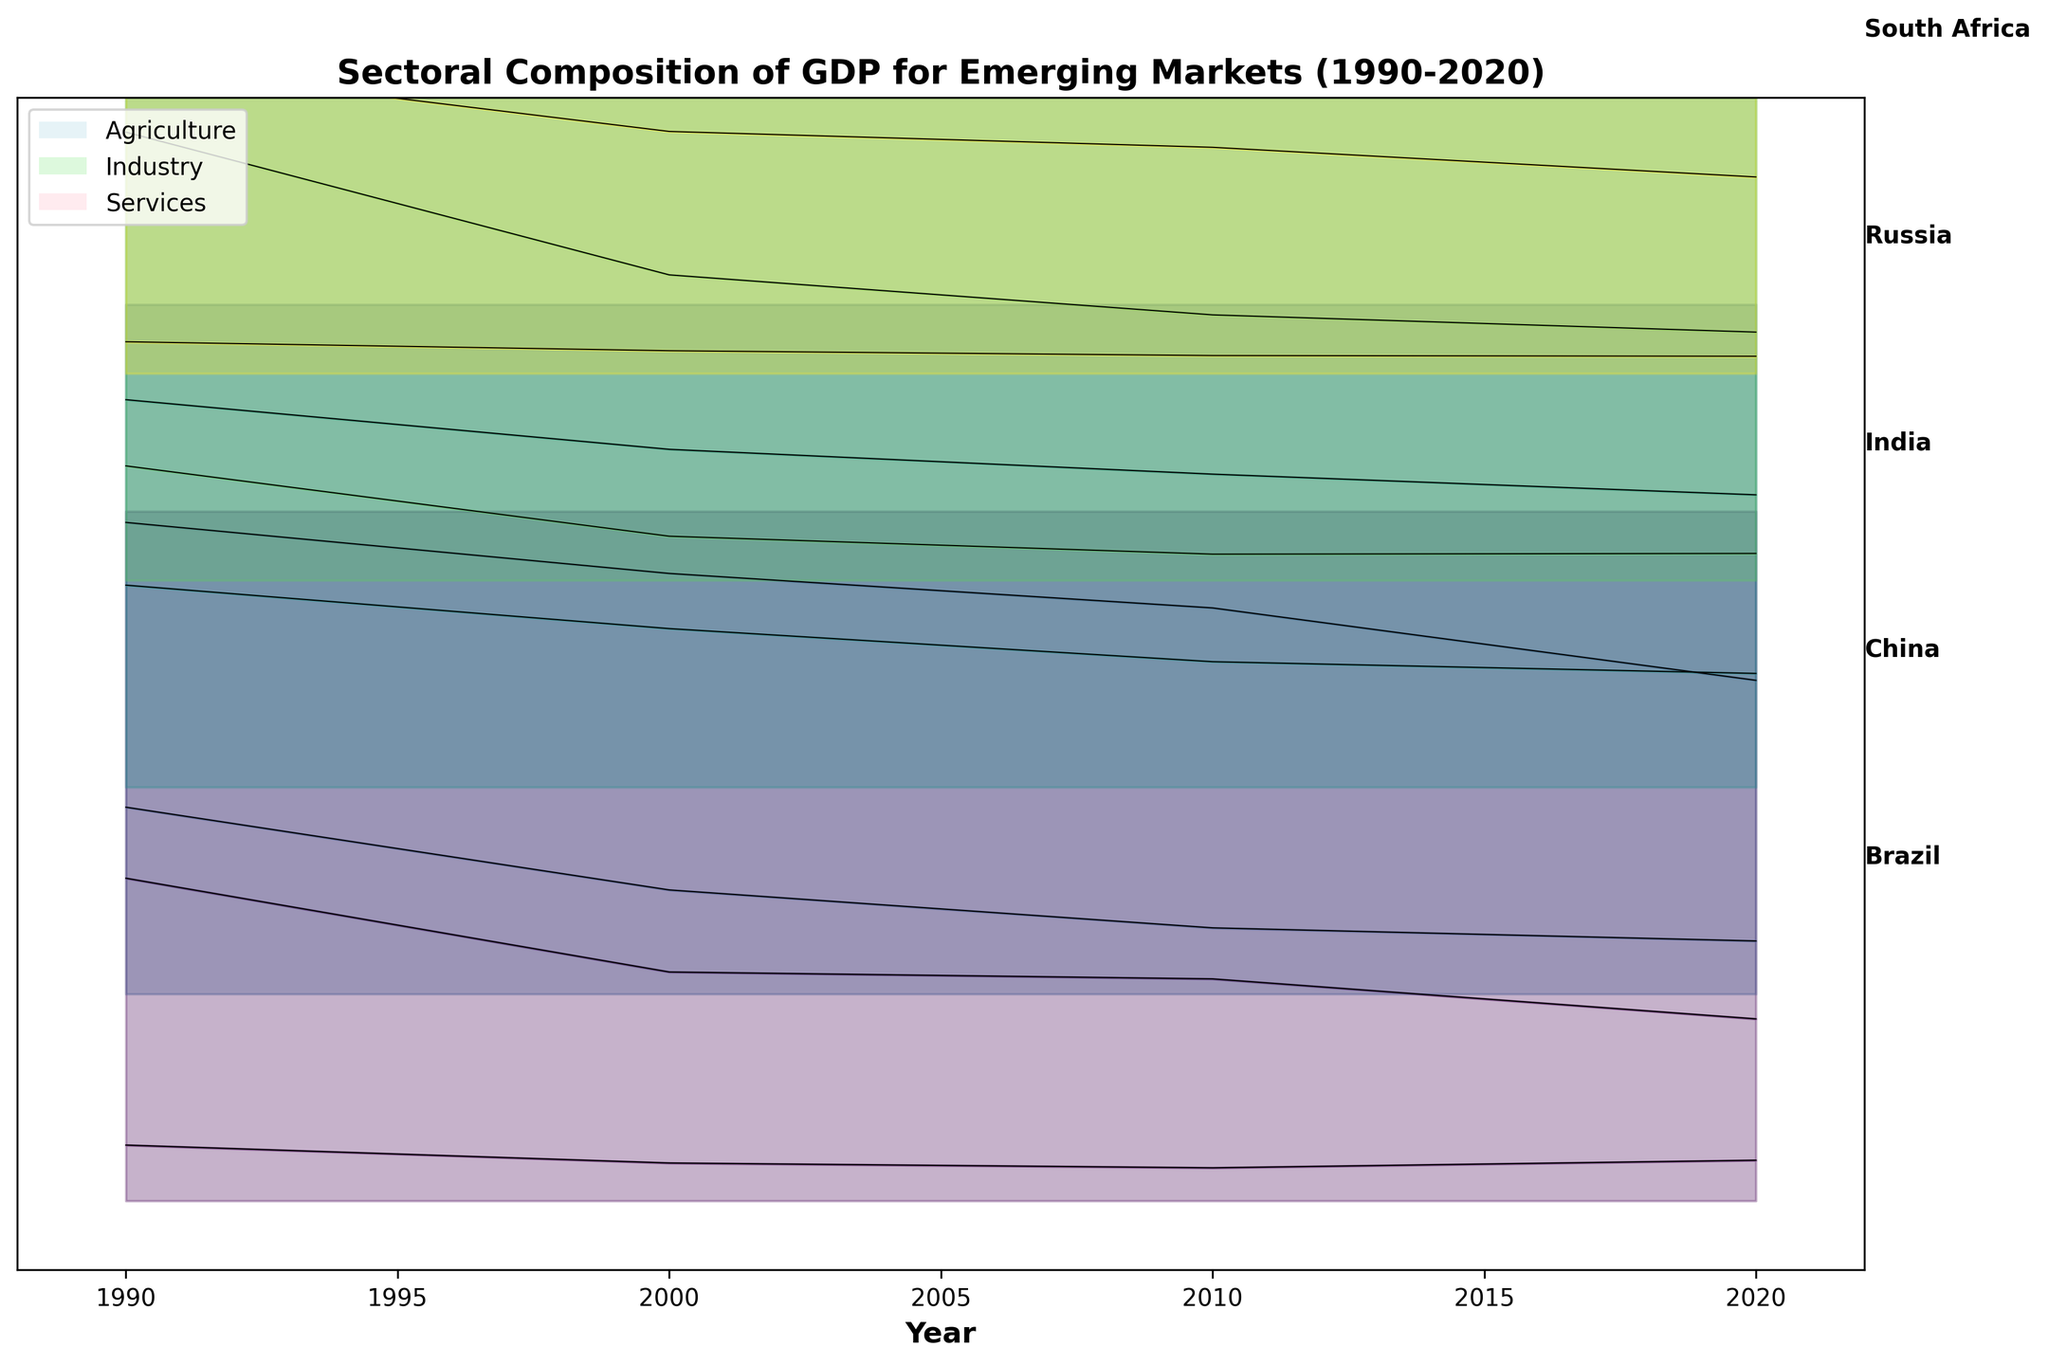What are the three main sectors plotted in the figure? The titles of the layers and the legend indicate that the three main sectors are Agriculture, Industry, and Services.
Answer: Agriculture, Industry, and Services Which country had the highest percentage of Agriculture in GDP in the year 1990? Observing the leftmost sections for 1990, China had the highest value for Agriculture.
Answer: China Has the Services sector increased or decreased in Brazil from 1990 to 2020? By looking at the height of the Services layer for Brazil (topmost bands), it has increased, as the band in 2020 is taller than in 1990.
Answer: Increased What is the approximate percentage increase in Services for South Africa from 1990 to 2020? In 1990, the Services share for South Africa was around 55.3%, and in 2020 it was 71.5%. The difference is 71.5 - 55.3 = 16.2%
Answer: 16.2% Compare the Industry sector percentages between India and Russia in 2020. Which country had a higher value? Looking at the heights of the Industry bands for India and Russia in 2020, Russia has a slightly higher Industry percentage.
Answer: Russia For which sector do we see the most significant decline in China from 1990 to 2020? Examining the three bands for China from left to right, the Agriculture sector shows the most significant decline.
Answer: Agriculture What does the height of the bands represent in this figure? The height of each band represents the percentage contribution to GDP of the respective sector (Agriculture, Industry, Services) for each country and year.
Answer: Percentage contribution to GDP What trend can be observed in the Industry sector for Russia from 1990 to 2020? The Industry sector for Russia starts high and decreases over the decades, indicating a downward trend.
Answer: Downward trend Which country shows the least variation in its Agriculture sector over the decades? By observing the Agriculture bands (bottommost layers) for all countries, South Africa shows the least variation.
Answer: South Africa 